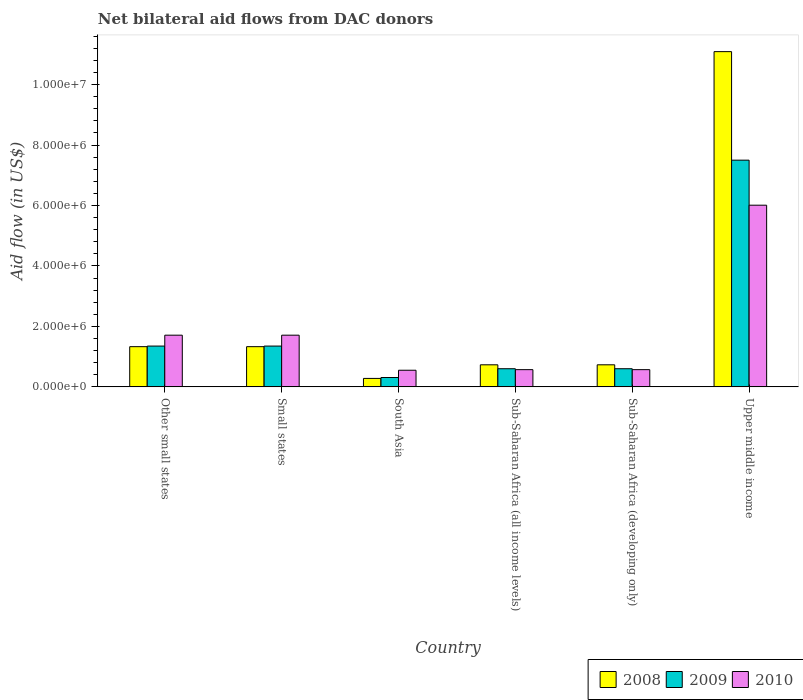How many different coloured bars are there?
Keep it short and to the point. 3. Are the number of bars on each tick of the X-axis equal?
Provide a succinct answer. Yes. How many bars are there on the 5th tick from the left?
Provide a succinct answer. 3. How many bars are there on the 2nd tick from the right?
Offer a terse response. 3. What is the label of the 6th group of bars from the left?
Your answer should be compact. Upper middle income. What is the net bilateral aid flow in 2009 in Upper middle income?
Give a very brief answer. 7.50e+06. Across all countries, what is the maximum net bilateral aid flow in 2009?
Your response must be concise. 7.50e+06. Across all countries, what is the minimum net bilateral aid flow in 2010?
Provide a short and direct response. 5.50e+05. In which country was the net bilateral aid flow in 2009 maximum?
Provide a succinct answer. Upper middle income. What is the total net bilateral aid flow in 2009 in the graph?
Keep it short and to the point. 1.17e+07. What is the difference between the net bilateral aid flow in 2010 in Sub-Saharan Africa (developing only) and that in Upper middle income?
Keep it short and to the point. -5.44e+06. What is the difference between the net bilateral aid flow in 2009 in Other small states and the net bilateral aid flow in 2010 in Sub-Saharan Africa (developing only)?
Provide a succinct answer. 7.80e+05. What is the average net bilateral aid flow in 2010 per country?
Keep it short and to the point. 1.85e+06. What is the difference between the net bilateral aid flow of/in 2009 and net bilateral aid flow of/in 2010 in Sub-Saharan Africa (developing only)?
Offer a very short reply. 3.00e+04. In how many countries, is the net bilateral aid flow in 2010 greater than 8400000 US$?
Make the answer very short. 0. What is the ratio of the net bilateral aid flow in 2010 in Other small states to that in Sub-Saharan Africa (all income levels)?
Your response must be concise. 3. Is the difference between the net bilateral aid flow in 2009 in Small states and Sub-Saharan Africa (developing only) greater than the difference between the net bilateral aid flow in 2010 in Small states and Sub-Saharan Africa (developing only)?
Offer a terse response. No. What is the difference between the highest and the second highest net bilateral aid flow in 2010?
Keep it short and to the point. 4.30e+06. What is the difference between the highest and the lowest net bilateral aid flow in 2008?
Offer a very short reply. 1.08e+07. Is the sum of the net bilateral aid flow in 2009 in Other small states and Sub-Saharan Africa (all income levels) greater than the maximum net bilateral aid flow in 2010 across all countries?
Make the answer very short. No. What does the 3rd bar from the left in South Asia represents?
Your answer should be compact. 2010. What does the 2nd bar from the right in South Asia represents?
Give a very brief answer. 2009. Is it the case that in every country, the sum of the net bilateral aid flow in 2009 and net bilateral aid flow in 2008 is greater than the net bilateral aid flow in 2010?
Offer a very short reply. Yes. Are all the bars in the graph horizontal?
Offer a terse response. No. What is the difference between two consecutive major ticks on the Y-axis?
Provide a short and direct response. 2.00e+06. Does the graph contain any zero values?
Make the answer very short. No. How many legend labels are there?
Give a very brief answer. 3. What is the title of the graph?
Keep it short and to the point. Net bilateral aid flows from DAC donors. Does "1985" appear as one of the legend labels in the graph?
Your response must be concise. No. What is the label or title of the X-axis?
Provide a succinct answer. Country. What is the label or title of the Y-axis?
Offer a very short reply. Aid flow (in US$). What is the Aid flow (in US$) of 2008 in Other small states?
Provide a succinct answer. 1.33e+06. What is the Aid flow (in US$) in 2009 in Other small states?
Provide a succinct answer. 1.35e+06. What is the Aid flow (in US$) in 2010 in Other small states?
Make the answer very short. 1.71e+06. What is the Aid flow (in US$) in 2008 in Small states?
Offer a terse response. 1.33e+06. What is the Aid flow (in US$) of 2009 in Small states?
Make the answer very short. 1.35e+06. What is the Aid flow (in US$) in 2010 in Small states?
Your answer should be very brief. 1.71e+06. What is the Aid flow (in US$) of 2008 in South Asia?
Provide a succinct answer. 2.80e+05. What is the Aid flow (in US$) in 2008 in Sub-Saharan Africa (all income levels)?
Ensure brevity in your answer.  7.30e+05. What is the Aid flow (in US$) in 2010 in Sub-Saharan Africa (all income levels)?
Ensure brevity in your answer.  5.70e+05. What is the Aid flow (in US$) in 2008 in Sub-Saharan Africa (developing only)?
Ensure brevity in your answer.  7.30e+05. What is the Aid flow (in US$) in 2010 in Sub-Saharan Africa (developing only)?
Ensure brevity in your answer.  5.70e+05. What is the Aid flow (in US$) in 2008 in Upper middle income?
Ensure brevity in your answer.  1.11e+07. What is the Aid flow (in US$) in 2009 in Upper middle income?
Offer a terse response. 7.50e+06. What is the Aid flow (in US$) in 2010 in Upper middle income?
Your response must be concise. 6.01e+06. Across all countries, what is the maximum Aid flow (in US$) of 2008?
Provide a short and direct response. 1.11e+07. Across all countries, what is the maximum Aid flow (in US$) in 2009?
Your answer should be very brief. 7.50e+06. Across all countries, what is the maximum Aid flow (in US$) in 2010?
Make the answer very short. 6.01e+06. Across all countries, what is the minimum Aid flow (in US$) of 2010?
Your response must be concise. 5.50e+05. What is the total Aid flow (in US$) of 2008 in the graph?
Your answer should be compact. 1.55e+07. What is the total Aid flow (in US$) in 2009 in the graph?
Your answer should be very brief. 1.17e+07. What is the total Aid flow (in US$) of 2010 in the graph?
Give a very brief answer. 1.11e+07. What is the difference between the Aid flow (in US$) in 2009 in Other small states and that in Small states?
Keep it short and to the point. 0. What is the difference between the Aid flow (in US$) in 2010 in Other small states and that in Small states?
Keep it short and to the point. 0. What is the difference between the Aid flow (in US$) of 2008 in Other small states and that in South Asia?
Offer a terse response. 1.05e+06. What is the difference between the Aid flow (in US$) in 2009 in Other small states and that in South Asia?
Provide a succinct answer. 1.04e+06. What is the difference between the Aid flow (in US$) of 2010 in Other small states and that in South Asia?
Give a very brief answer. 1.16e+06. What is the difference between the Aid flow (in US$) of 2009 in Other small states and that in Sub-Saharan Africa (all income levels)?
Offer a terse response. 7.50e+05. What is the difference between the Aid flow (in US$) in 2010 in Other small states and that in Sub-Saharan Africa (all income levels)?
Offer a very short reply. 1.14e+06. What is the difference between the Aid flow (in US$) in 2009 in Other small states and that in Sub-Saharan Africa (developing only)?
Provide a succinct answer. 7.50e+05. What is the difference between the Aid flow (in US$) of 2010 in Other small states and that in Sub-Saharan Africa (developing only)?
Keep it short and to the point. 1.14e+06. What is the difference between the Aid flow (in US$) in 2008 in Other small states and that in Upper middle income?
Make the answer very short. -9.76e+06. What is the difference between the Aid flow (in US$) of 2009 in Other small states and that in Upper middle income?
Your answer should be compact. -6.15e+06. What is the difference between the Aid flow (in US$) in 2010 in Other small states and that in Upper middle income?
Make the answer very short. -4.30e+06. What is the difference between the Aid flow (in US$) of 2008 in Small states and that in South Asia?
Provide a short and direct response. 1.05e+06. What is the difference between the Aid flow (in US$) of 2009 in Small states and that in South Asia?
Your answer should be compact. 1.04e+06. What is the difference between the Aid flow (in US$) in 2010 in Small states and that in South Asia?
Keep it short and to the point. 1.16e+06. What is the difference between the Aid flow (in US$) in 2009 in Small states and that in Sub-Saharan Africa (all income levels)?
Provide a succinct answer. 7.50e+05. What is the difference between the Aid flow (in US$) of 2010 in Small states and that in Sub-Saharan Africa (all income levels)?
Make the answer very short. 1.14e+06. What is the difference between the Aid flow (in US$) in 2009 in Small states and that in Sub-Saharan Africa (developing only)?
Your answer should be compact. 7.50e+05. What is the difference between the Aid flow (in US$) of 2010 in Small states and that in Sub-Saharan Africa (developing only)?
Provide a short and direct response. 1.14e+06. What is the difference between the Aid flow (in US$) in 2008 in Small states and that in Upper middle income?
Your answer should be compact. -9.76e+06. What is the difference between the Aid flow (in US$) of 2009 in Small states and that in Upper middle income?
Your answer should be very brief. -6.15e+06. What is the difference between the Aid flow (in US$) of 2010 in Small states and that in Upper middle income?
Keep it short and to the point. -4.30e+06. What is the difference between the Aid flow (in US$) in 2008 in South Asia and that in Sub-Saharan Africa (all income levels)?
Keep it short and to the point. -4.50e+05. What is the difference between the Aid flow (in US$) in 2009 in South Asia and that in Sub-Saharan Africa (all income levels)?
Give a very brief answer. -2.90e+05. What is the difference between the Aid flow (in US$) of 2008 in South Asia and that in Sub-Saharan Africa (developing only)?
Offer a very short reply. -4.50e+05. What is the difference between the Aid flow (in US$) of 2008 in South Asia and that in Upper middle income?
Provide a short and direct response. -1.08e+07. What is the difference between the Aid flow (in US$) in 2009 in South Asia and that in Upper middle income?
Provide a succinct answer. -7.19e+06. What is the difference between the Aid flow (in US$) in 2010 in South Asia and that in Upper middle income?
Your answer should be compact. -5.46e+06. What is the difference between the Aid flow (in US$) of 2008 in Sub-Saharan Africa (all income levels) and that in Upper middle income?
Give a very brief answer. -1.04e+07. What is the difference between the Aid flow (in US$) of 2009 in Sub-Saharan Africa (all income levels) and that in Upper middle income?
Keep it short and to the point. -6.90e+06. What is the difference between the Aid flow (in US$) of 2010 in Sub-Saharan Africa (all income levels) and that in Upper middle income?
Offer a very short reply. -5.44e+06. What is the difference between the Aid flow (in US$) in 2008 in Sub-Saharan Africa (developing only) and that in Upper middle income?
Provide a short and direct response. -1.04e+07. What is the difference between the Aid flow (in US$) in 2009 in Sub-Saharan Africa (developing only) and that in Upper middle income?
Your answer should be compact. -6.90e+06. What is the difference between the Aid flow (in US$) of 2010 in Sub-Saharan Africa (developing only) and that in Upper middle income?
Your response must be concise. -5.44e+06. What is the difference between the Aid flow (in US$) in 2008 in Other small states and the Aid flow (in US$) in 2009 in Small states?
Offer a terse response. -2.00e+04. What is the difference between the Aid flow (in US$) of 2008 in Other small states and the Aid flow (in US$) of 2010 in Small states?
Provide a short and direct response. -3.80e+05. What is the difference between the Aid flow (in US$) of 2009 in Other small states and the Aid flow (in US$) of 2010 in Small states?
Your answer should be compact. -3.60e+05. What is the difference between the Aid flow (in US$) of 2008 in Other small states and the Aid flow (in US$) of 2009 in South Asia?
Your answer should be very brief. 1.02e+06. What is the difference between the Aid flow (in US$) in 2008 in Other small states and the Aid flow (in US$) in 2010 in South Asia?
Your response must be concise. 7.80e+05. What is the difference between the Aid flow (in US$) in 2009 in Other small states and the Aid flow (in US$) in 2010 in South Asia?
Your response must be concise. 8.00e+05. What is the difference between the Aid flow (in US$) in 2008 in Other small states and the Aid flow (in US$) in 2009 in Sub-Saharan Africa (all income levels)?
Keep it short and to the point. 7.30e+05. What is the difference between the Aid flow (in US$) of 2008 in Other small states and the Aid flow (in US$) of 2010 in Sub-Saharan Africa (all income levels)?
Make the answer very short. 7.60e+05. What is the difference between the Aid flow (in US$) of 2009 in Other small states and the Aid flow (in US$) of 2010 in Sub-Saharan Africa (all income levels)?
Keep it short and to the point. 7.80e+05. What is the difference between the Aid flow (in US$) of 2008 in Other small states and the Aid flow (in US$) of 2009 in Sub-Saharan Africa (developing only)?
Offer a terse response. 7.30e+05. What is the difference between the Aid flow (in US$) of 2008 in Other small states and the Aid flow (in US$) of 2010 in Sub-Saharan Africa (developing only)?
Provide a succinct answer. 7.60e+05. What is the difference between the Aid flow (in US$) of 2009 in Other small states and the Aid flow (in US$) of 2010 in Sub-Saharan Africa (developing only)?
Offer a very short reply. 7.80e+05. What is the difference between the Aid flow (in US$) of 2008 in Other small states and the Aid flow (in US$) of 2009 in Upper middle income?
Make the answer very short. -6.17e+06. What is the difference between the Aid flow (in US$) of 2008 in Other small states and the Aid flow (in US$) of 2010 in Upper middle income?
Make the answer very short. -4.68e+06. What is the difference between the Aid flow (in US$) in 2009 in Other small states and the Aid flow (in US$) in 2010 in Upper middle income?
Your answer should be very brief. -4.66e+06. What is the difference between the Aid flow (in US$) in 2008 in Small states and the Aid flow (in US$) in 2009 in South Asia?
Offer a terse response. 1.02e+06. What is the difference between the Aid flow (in US$) in 2008 in Small states and the Aid flow (in US$) in 2010 in South Asia?
Provide a succinct answer. 7.80e+05. What is the difference between the Aid flow (in US$) of 2009 in Small states and the Aid flow (in US$) of 2010 in South Asia?
Give a very brief answer. 8.00e+05. What is the difference between the Aid flow (in US$) of 2008 in Small states and the Aid flow (in US$) of 2009 in Sub-Saharan Africa (all income levels)?
Give a very brief answer. 7.30e+05. What is the difference between the Aid flow (in US$) of 2008 in Small states and the Aid flow (in US$) of 2010 in Sub-Saharan Africa (all income levels)?
Offer a terse response. 7.60e+05. What is the difference between the Aid flow (in US$) in 2009 in Small states and the Aid flow (in US$) in 2010 in Sub-Saharan Africa (all income levels)?
Provide a succinct answer. 7.80e+05. What is the difference between the Aid flow (in US$) of 2008 in Small states and the Aid flow (in US$) of 2009 in Sub-Saharan Africa (developing only)?
Your answer should be compact. 7.30e+05. What is the difference between the Aid flow (in US$) of 2008 in Small states and the Aid flow (in US$) of 2010 in Sub-Saharan Africa (developing only)?
Offer a very short reply. 7.60e+05. What is the difference between the Aid flow (in US$) in 2009 in Small states and the Aid flow (in US$) in 2010 in Sub-Saharan Africa (developing only)?
Make the answer very short. 7.80e+05. What is the difference between the Aid flow (in US$) of 2008 in Small states and the Aid flow (in US$) of 2009 in Upper middle income?
Ensure brevity in your answer.  -6.17e+06. What is the difference between the Aid flow (in US$) in 2008 in Small states and the Aid flow (in US$) in 2010 in Upper middle income?
Offer a terse response. -4.68e+06. What is the difference between the Aid flow (in US$) of 2009 in Small states and the Aid flow (in US$) of 2010 in Upper middle income?
Ensure brevity in your answer.  -4.66e+06. What is the difference between the Aid flow (in US$) of 2008 in South Asia and the Aid flow (in US$) of 2009 in Sub-Saharan Africa (all income levels)?
Offer a very short reply. -3.20e+05. What is the difference between the Aid flow (in US$) in 2009 in South Asia and the Aid flow (in US$) in 2010 in Sub-Saharan Africa (all income levels)?
Your answer should be very brief. -2.60e+05. What is the difference between the Aid flow (in US$) of 2008 in South Asia and the Aid flow (in US$) of 2009 in Sub-Saharan Africa (developing only)?
Offer a very short reply. -3.20e+05. What is the difference between the Aid flow (in US$) of 2008 in South Asia and the Aid flow (in US$) of 2010 in Sub-Saharan Africa (developing only)?
Your response must be concise. -2.90e+05. What is the difference between the Aid flow (in US$) in 2008 in South Asia and the Aid flow (in US$) in 2009 in Upper middle income?
Offer a terse response. -7.22e+06. What is the difference between the Aid flow (in US$) of 2008 in South Asia and the Aid flow (in US$) of 2010 in Upper middle income?
Offer a very short reply. -5.73e+06. What is the difference between the Aid flow (in US$) in 2009 in South Asia and the Aid flow (in US$) in 2010 in Upper middle income?
Your answer should be compact. -5.70e+06. What is the difference between the Aid flow (in US$) in 2009 in Sub-Saharan Africa (all income levels) and the Aid flow (in US$) in 2010 in Sub-Saharan Africa (developing only)?
Your answer should be compact. 3.00e+04. What is the difference between the Aid flow (in US$) in 2008 in Sub-Saharan Africa (all income levels) and the Aid flow (in US$) in 2009 in Upper middle income?
Make the answer very short. -6.77e+06. What is the difference between the Aid flow (in US$) in 2008 in Sub-Saharan Africa (all income levels) and the Aid flow (in US$) in 2010 in Upper middle income?
Make the answer very short. -5.28e+06. What is the difference between the Aid flow (in US$) in 2009 in Sub-Saharan Africa (all income levels) and the Aid flow (in US$) in 2010 in Upper middle income?
Offer a terse response. -5.41e+06. What is the difference between the Aid flow (in US$) of 2008 in Sub-Saharan Africa (developing only) and the Aid flow (in US$) of 2009 in Upper middle income?
Your response must be concise. -6.77e+06. What is the difference between the Aid flow (in US$) in 2008 in Sub-Saharan Africa (developing only) and the Aid flow (in US$) in 2010 in Upper middle income?
Offer a terse response. -5.28e+06. What is the difference between the Aid flow (in US$) in 2009 in Sub-Saharan Africa (developing only) and the Aid flow (in US$) in 2010 in Upper middle income?
Your answer should be compact. -5.41e+06. What is the average Aid flow (in US$) of 2008 per country?
Your answer should be compact. 2.58e+06. What is the average Aid flow (in US$) in 2009 per country?
Your answer should be compact. 1.95e+06. What is the average Aid flow (in US$) of 2010 per country?
Offer a terse response. 1.85e+06. What is the difference between the Aid flow (in US$) in 2008 and Aid flow (in US$) in 2010 in Other small states?
Offer a very short reply. -3.80e+05. What is the difference between the Aid flow (in US$) in 2009 and Aid flow (in US$) in 2010 in Other small states?
Provide a short and direct response. -3.60e+05. What is the difference between the Aid flow (in US$) of 2008 and Aid flow (in US$) of 2009 in Small states?
Offer a terse response. -2.00e+04. What is the difference between the Aid flow (in US$) of 2008 and Aid flow (in US$) of 2010 in Small states?
Offer a very short reply. -3.80e+05. What is the difference between the Aid flow (in US$) of 2009 and Aid flow (in US$) of 2010 in Small states?
Your answer should be compact. -3.60e+05. What is the difference between the Aid flow (in US$) in 2009 and Aid flow (in US$) in 2010 in Sub-Saharan Africa (all income levels)?
Make the answer very short. 3.00e+04. What is the difference between the Aid flow (in US$) in 2008 and Aid flow (in US$) in 2009 in Sub-Saharan Africa (developing only)?
Provide a short and direct response. 1.30e+05. What is the difference between the Aid flow (in US$) of 2008 and Aid flow (in US$) of 2009 in Upper middle income?
Your answer should be very brief. 3.59e+06. What is the difference between the Aid flow (in US$) of 2008 and Aid flow (in US$) of 2010 in Upper middle income?
Give a very brief answer. 5.08e+06. What is the difference between the Aid flow (in US$) in 2009 and Aid flow (in US$) in 2010 in Upper middle income?
Keep it short and to the point. 1.49e+06. What is the ratio of the Aid flow (in US$) in 2008 in Other small states to that in South Asia?
Ensure brevity in your answer.  4.75. What is the ratio of the Aid flow (in US$) of 2009 in Other small states to that in South Asia?
Ensure brevity in your answer.  4.35. What is the ratio of the Aid flow (in US$) of 2010 in Other small states to that in South Asia?
Your response must be concise. 3.11. What is the ratio of the Aid flow (in US$) in 2008 in Other small states to that in Sub-Saharan Africa (all income levels)?
Your response must be concise. 1.82. What is the ratio of the Aid flow (in US$) of 2009 in Other small states to that in Sub-Saharan Africa (all income levels)?
Your answer should be compact. 2.25. What is the ratio of the Aid flow (in US$) of 2010 in Other small states to that in Sub-Saharan Africa (all income levels)?
Provide a short and direct response. 3. What is the ratio of the Aid flow (in US$) in 2008 in Other small states to that in Sub-Saharan Africa (developing only)?
Your answer should be very brief. 1.82. What is the ratio of the Aid flow (in US$) of 2009 in Other small states to that in Sub-Saharan Africa (developing only)?
Provide a short and direct response. 2.25. What is the ratio of the Aid flow (in US$) of 2010 in Other small states to that in Sub-Saharan Africa (developing only)?
Offer a very short reply. 3. What is the ratio of the Aid flow (in US$) of 2008 in Other small states to that in Upper middle income?
Your answer should be compact. 0.12. What is the ratio of the Aid flow (in US$) of 2009 in Other small states to that in Upper middle income?
Your answer should be very brief. 0.18. What is the ratio of the Aid flow (in US$) of 2010 in Other small states to that in Upper middle income?
Make the answer very short. 0.28. What is the ratio of the Aid flow (in US$) of 2008 in Small states to that in South Asia?
Your answer should be compact. 4.75. What is the ratio of the Aid flow (in US$) in 2009 in Small states to that in South Asia?
Your answer should be very brief. 4.35. What is the ratio of the Aid flow (in US$) of 2010 in Small states to that in South Asia?
Offer a terse response. 3.11. What is the ratio of the Aid flow (in US$) in 2008 in Small states to that in Sub-Saharan Africa (all income levels)?
Your answer should be very brief. 1.82. What is the ratio of the Aid flow (in US$) in 2009 in Small states to that in Sub-Saharan Africa (all income levels)?
Provide a succinct answer. 2.25. What is the ratio of the Aid flow (in US$) of 2010 in Small states to that in Sub-Saharan Africa (all income levels)?
Your answer should be compact. 3. What is the ratio of the Aid flow (in US$) of 2008 in Small states to that in Sub-Saharan Africa (developing only)?
Offer a terse response. 1.82. What is the ratio of the Aid flow (in US$) in 2009 in Small states to that in Sub-Saharan Africa (developing only)?
Your answer should be very brief. 2.25. What is the ratio of the Aid flow (in US$) of 2008 in Small states to that in Upper middle income?
Offer a very short reply. 0.12. What is the ratio of the Aid flow (in US$) of 2009 in Small states to that in Upper middle income?
Your response must be concise. 0.18. What is the ratio of the Aid flow (in US$) in 2010 in Small states to that in Upper middle income?
Ensure brevity in your answer.  0.28. What is the ratio of the Aid flow (in US$) of 2008 in South Asia to that in Sub-Saharan Africa (all income levels)?
Your answer should be very brief. 0.38. What is the ratio of the Aid flow (in US$) in 2009 in South Asia to that in Sub-Saharan Africa (all income levels)?
Your response must be concise. 0.52. What is the ratio of the Aid flow (in US$) of 2010 in South Asia to that in Sub-Saharan Africa (all income levels)?
Give a very brief answer. 0.96. What is the ratio of the Aid flow (in US$) in 2008 in South Asia to that in Sub-Saharan Africa (developing only)?
Provide a succinct answer. 0.38. What is the ratio of the Aid flow (in US$) of 2009 in South Asia to that in Sub-Saharan Africa (developing only)?
Give a very brief answer. 0.52. What is the ratio of the Aid flow (in US$) of 2010 in South Asia to that in Sub-Saharan Africa (developing only)?
Provide a succinct answer. 0.96. What is the ratio of the Aid flow (in US$) of 2008 in South Asia to that in Upper middle income?
Make the answer very short. 0.03. What is the ratio of the Aid flow (in US$) in 2009 in South Asia to that in Upper middle income?
Make the answer very short. 0.04. What is the ratio of the Aid flow (in US$) in 2010 in South Asia to that in Upper middle income?
Your response must be concise. 0.09. What is the ratio of the Aid flow (in US$) in 2008 in Sub-Saharan Africa (all income levels) to that in Sub-Saharan Africa (developing only)?
Keep it short and to the point. 1. What is the ratio of the Aid flow (in US$) in 2008 in Sub-Saharan Africa (all income levels) to that in Upper middle income?
Offer a very short reply. 0.07. What is the ratio of the Aid flow (in US$) in 2009 in Sub-Saharan Africa (all income levels) to that in Upper middle income?
Provide a short and direct response. 0.08. What is the ratio of the Aid flow (in US$) of 2010 in Sub-Saharan Africa (all income levels) to that in Upper middle income?
Your answer should be very brief. 0.09. What is the ratio of the Aid flow (in US$) in 2008 in Sub-Saharan Africa (developing only) to that in Upper middle income?
Provide a succinct answer. 0.07. What is the ratio of the Aid flow (in US$) of 2009 in Sub-Saharan Africa (developing only) to that in Upper middle income?
Your answer should be very brief. 0.08. What is the ratio of the Aid flow (in US$) in 2010 in Sub-Saharan Africa (developing only) to that in Upper middle income?
Ensure brevity in your answer.  0.09. What is the difference between the highest and the second highest Aid flow (in US$) in 2008?
Your response must be concise. 9.76e+06. What is the difference between the highest and the second highest Aid flow (in US$) of 2009?
Provide a short and direct response. 6.15e+06. What is the difference between the highest and the second highest Aid flow (in US$) of 2010?
Give a very brief answer. 4.30e+06. What is the difference between the highest and the lowest Aid flow (in US$) of 2008?
Ensure brevity in your answer.  1.08e+07. What is the difference between the highest and the lowest Aid flow (in US$) in 2009?
Provide a short and direct response. 7.19e+06. What is the difference between the highest and the lowest Aid flow (in US$) of 2010?
Your answer should be compact. 5.46e+06. 